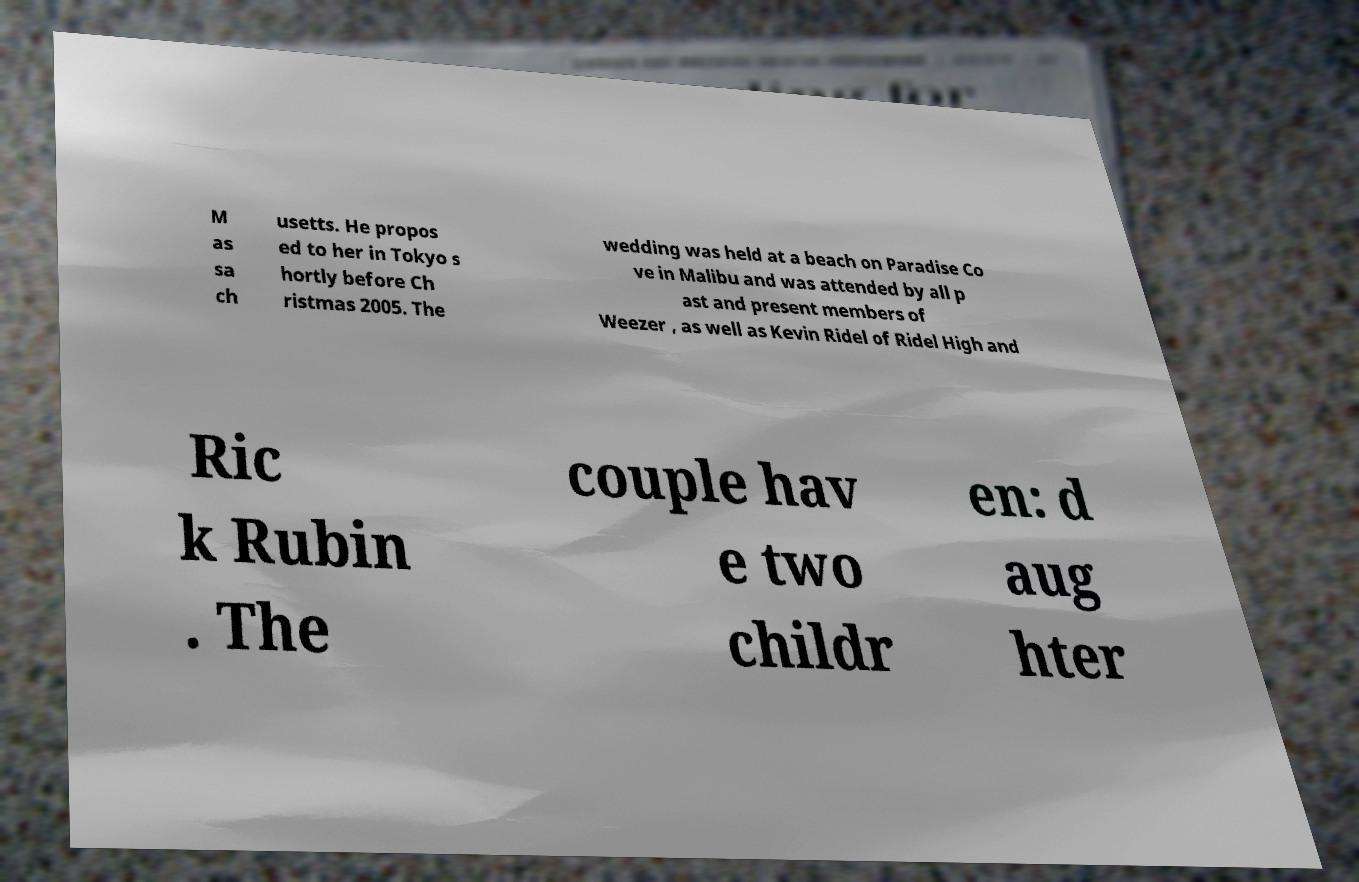For documentation purposes, I need the text within this image transcribed. Could you provide that? M as sa ch usetts. He propos ed to her in Tokyo s hortly before Ch ristmas 2005. The wedding was held at a beach on Paradise Co ve in Malibu and was attended by all p ast and present members of Weezer , as well as Kevin Ridel of Ridel High and Ric k Rubin . The couple hav e two childr en: d aug hter 